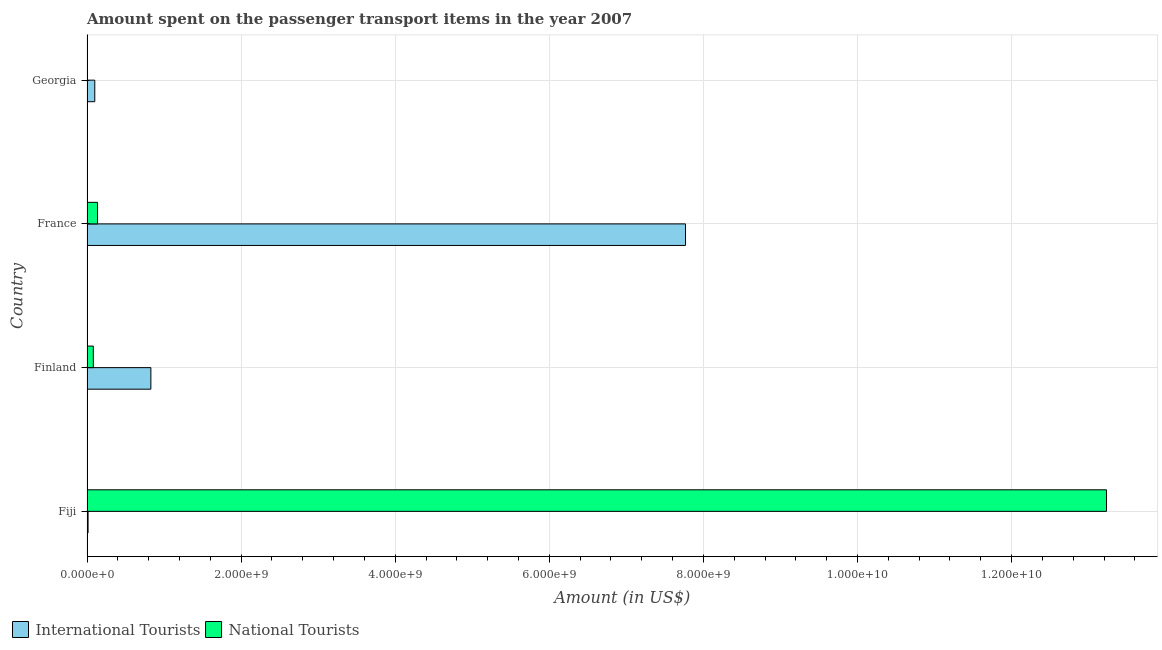How many groups of bars are there?
Offer a terse response. 4. Are the number of bars on each tick of the Y-axis equal?
Offer a very short reply. Yes. How many bars are there on the 1st tick from the bottom?
Give a very brief answer. 2. What is the label of the 2nd group of bars from the top?
Your answer should be very brief. France. What is the amount spent on transport items of international tourists in France?
Your answer should be compact. 7.77e+09. Across all countries, what is the maximum amount spent on transport items of national tourists?
Your answer should be very brief. 1.32e+1. Across all countries, what is the minimum amount spent on transport items of international tourists?
Keep it short and to the point. 1.40e+07. In which country was the amount spent on transport items of international tourists maximum?
Your response must be concise. France. In which country was the amount spent on transport items of international tourists minimum?
Keep it short and to the point. Fiji. What is the total amount spent on transport items of international tourists in the graph?
Provide a short and direct response. 8.71e+09. What is the difference between the amount spent on transport items of international tourists in Fiji and that in France?
Give a very brief answer. -7.75e+09. What is the difference between the amount spent on transport items of national tourists in Finland and the amount spent on transport items of international tourists in France?
Keep it short and to the point. -7.69e+09. What is the average amount spent on transport items of national tourists per country?
Give a very brief answer. 3.36e+09. What is the difference between the amount spent on transport items of international tourists and amount spent on transport items of national tourists in Georgia?
Offer a terse response. 1.00e+08. What is the ratio of the amount spent on transport items of national tourists in France to that in Georgia?
Ensure brevity in your answer.  152.22. What is the difference between the highest and the second highest amount spent on transport items of national tourists?
Your answer should be very brief. 1.31e+1. What is the difference between the highest and the lowest amount spent on transport items of national tourists?
Make the answer very short. 1.32e+1. What does the 1st bar from the top in Finland represents?
Keep it short and to the point. National Tourists. What does the 1st bar from the bottom in France represents?
Your response must be concise. International Tourists. How many countries are there in the graph?
Keep it short and to the point. 4. What is the difference between two consecutive major ticks on the X-axis?
Keep it short and to the point. 2.00e+09. Are the values on the major ticks of X-axis written in scientific E-notation?
Your answer should be compact. Yes. Does the graph contain any zero values?
Offer a terse response. No. How many legend labels are there?
Your answer should be very brief. 2. What is the title of the graph?
Ensure brevity in your answer.  Amount spent on the passenger transport items in the year 2007. Does "Forest land" appear as one of the legend labels in the graph?
Offer a terse response. No. What is the label or title of the Y-axis?
Give a very brief answer. Country. What is the Amount (in US$) of International Tourists in Fiji?
Your response must be concise. 1.40e+07. What is the Amount (in US$) of National Tourists in Fiji?
Give a very brief answer. 1.32e+1. What is the Amount (in US$) in International Tourists in Finland?
Provide a succinct answer. 8.29e+08. What is the Amount (in US$) of National Tourists in Finland?
Offer a terse response. 8.20e+07. What is the Amount (in US$) in International Tourists in France?
Offer a very short reply. 7.77e+09. What is the Amount (in US$) of National Tourists in France?
Offer a terse response. 1.37e+08. What is the Amount (in US$) of International Tourists in Georgia?
Your answer should be compact. 1.01e+08. Across all countries, what is the maximum Amount (in US$) of International Tourists?
Ensure brevity in your answer.  7.77e+09. Across all countries, what is the maximum Amount (in US$) of National Tourists?
Your answer should be very brief. 1.32e+1. Across all countries, what is the minimum Amount (in US$) of International Tourists?
Offer a very short reply. 1.40e+07. Across all countries, what is the minimum Amount (in US$) in National Tourists?
Ensure brevity in your answer.  9.00e+05. What is the total Amount (in US$) in International Tourists in the graph?
Your response must be concise. 8.71e+09. What is the total Amount (in US$) in National Tourists in the graph?
Your answer should be very brief. 1.35e+1. What is the difference between the Amount (in US$) of International Tourists in Fiji and that in Finland?
Your answer should be compact. -8.15e+08. What is the difference between the Amount (in US$) in National Tourists in Fiji and that in Finland?
Provide a short and direct response. 1.32e+1. What is the difference between the Amount (in US$) in International Tourists in Fiji and that in France?
Ensure brevity in your answer.  -7.75e+09. What is the difference between the Amount (in US$) in National Tourists in Fiji and that in France?
Provide a succinct answer. 1.31e+1. What is the difference between the Amount (in US$) in International Tourists in Fiji and that in Georgia?
Your answer should be very brief. -8.70e+07. What is the difference between the Amount (in US$) of National Tourists in Fiji and that in Georgia?
Keep it short and to the point. 1.32e+1. What is the difference between the Amount (in US$) of International Tourists in Finland and that in France?
Your response must be concise. -6.94e+09. What is the difference between the Amount (in US$) of National Tourists in Finland and that in France?
Your response must be concise. -5.50e+07. What is the difference between the Amount (in US$) of International Tourists in Finland and that in Georgia?
Ensure brevity in your answer.  7.28e+08. What is the difference between the Amount (in US$) of National Tourists in Finland and that in Georgia?
Make the answer very short. 8.11e+07. What is the difference between the Amount (in US$) in International Tourists in France and that in Georgia?
Provide a short and direct response. 7.67e+09. What is the difference between the Amount (in US$) in National Tourists in France and that in Georgia?
Keep it short and to the point. 1.36e+08. What is the difference between the Amount (in US$) in International Tourists in Fiji and the Amount (in US$) in National Tourists in Finland?
Give a very brief answer. -6.80e+07. What is the difference between the Amount (in US$) of International Tourists in Fiji and the Amount (in US$) of National Tourists in France?
Make the answer very short. -1.23e+08. What is the difference between the Amount (in US$) in International Tourists in Fiji and the Amount (in US$) in National Tourists in Georgia?
Ensure brevity in your answer.  1.31e+07. What is the difference between the Amount (in US$) of International Tourists in Finland and the Amount (in US$) of National Tourists in France?
Your response must be concise. 6.92e+08. What is the difference between the Amount (in US$) in International Tourists in Finland and the Amount (in US$) in National Tourists in Georgia?
Give a very brief answer. 8.28e+08. What is the difference between the Amount (in US$) of International Tourists in France and the Amount (in US$) of National Tourists in Georgia?
Keep it short and to the point. 7.77e+09. What is the average Amount (in US$) in International Tourists per country?
Provide a succinct answer. 2.18e+09. What is the average Amount (in US$) in National Tourists per country?
Your answer should be compact. 3.36e+09. What is the difference between the Amount (in US$) in International Tourists and Amount (in US$) in National Tourists in Fiji?
Offer a terse response. -1.32e+1. What is the difference between the Amount (in US$) of International Tourists and Amount (in US$) of National Tourists in Finland?
Your answer should be very brief. 7.47e+08. What is the difference between the Amount (in US$) in International Tourists and Amount (in US$) in National Tourists in France?
Provide a succinct answer. 7.63e+09. What is the difference between the Amount (in US$) of International Tourists and Amount (in US$) of National Tourists in Georgia?
Give a very brief answer. 1.00e+08. What is the ratio of the Amount (in US$) in International Tourists in Fiji to that in Finland?
Your answer should be compact. 0.02. What is the ratio of the Amount (in US$) in National Tourists in Fiji to that in Finland?
Your answer should be very brief. 161.37. What is the ratio of the Amount (in US$) in International Tourists in Fiji to that in France?
Provide a short and direct response. 0. What is the ratio of the Amount (in US$) in National Tourists in Fiji to that in France?
Ensure brevity in your answer.  96.58. What is the ratio of the Amount (in US$) of International Tourists in Fiji to that in Georgia?
Ensure brevity in your answer.  0.14. What is the ratio of the Amount (in US$) of National Tourists in Fiji to that in Georgia?
Keep it short and to the point. 1.47e+04. What is the ratio of the Amount (in US$) in International Tourists in Finland to that in France?
Ensure brevity in your answer.  0.11. What is the ratio of the Amount (in US$) of National Tourists in Finland to that in France?
Make the answer very short. 0.6. What is the ratio of the Amount (in US$) of International Tourists in Finland to that in Georgia?
Offer a terse response. 8.21. What is the ratio of the Amount (in US$) of National Tourists in Finland to that in Georgia?
Give a very brief answer. 91.11. What is the ratio of the Amount (in US$) in International Tourists in France to that in Georgia?
Your answer should be compact. 76.91. What is the ratio of the Amount (in US$) in National Tourists in France to that in Georgia?
Ensure brevity in your answer.  152.22. What is the difference between the highest and the second highest Amount (in US$) of International Tourists?
Give a very brief answer. 6.94e+09. What is the difference between the highest and the second highest Amount (in US$) of National Tourists?
Make the answer very short. 1.31e+1. What is the difference between the highest and the lowest Amount (in US$) in International Tourists?
Ensure brevity in your answer.  7.75e+09. What is the difference between the highest and the lowest Amount (in US$) in National Tourists?
Provide a short and direct response. 1.32e+1. 